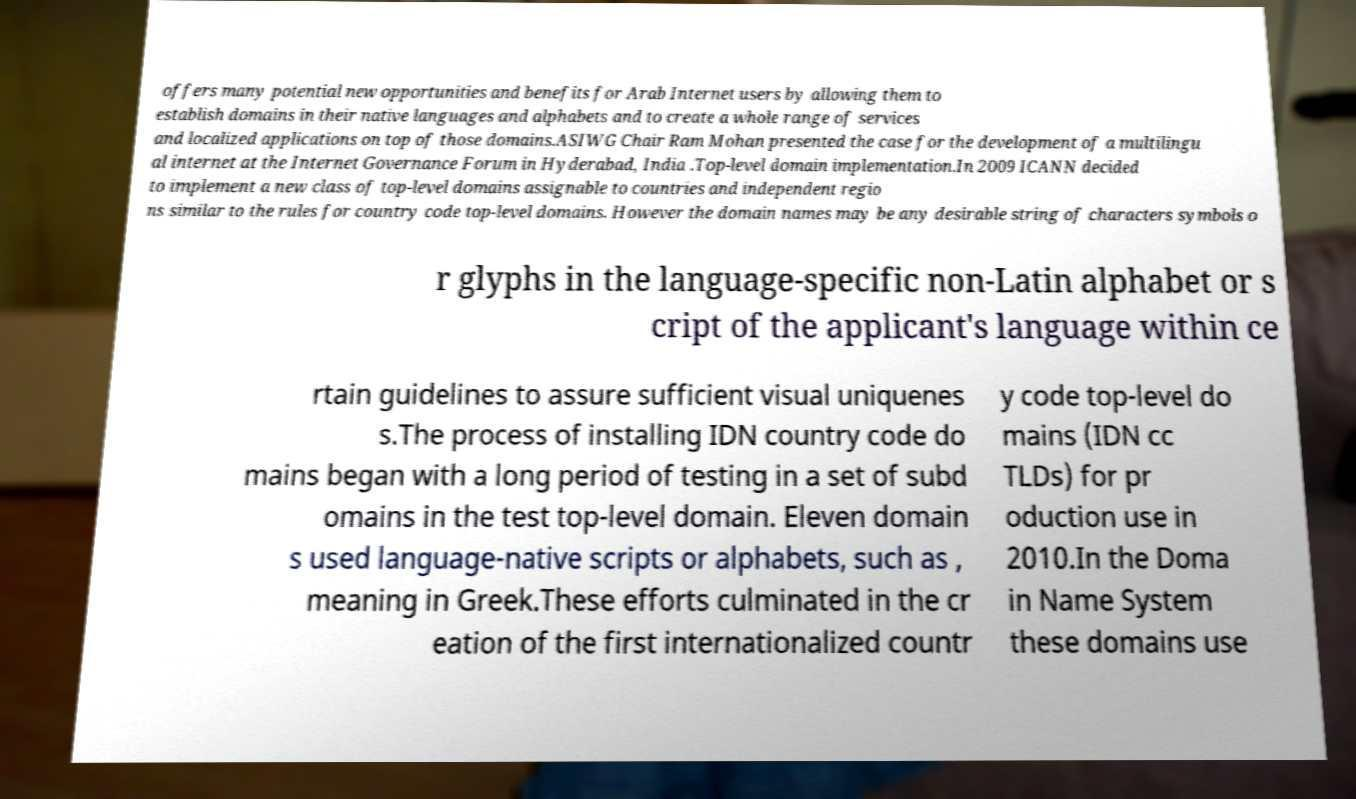There's text embedded in this image that I need extracted. Can you transcribe it verbatim? offers many potential new opportunities and benefits for Arab Internet users by allowing them to establish domains in their native languages and alphabets and to create a whole range of services and localized applications on top of those domains.ASIWG Chair Ram Mohan presented the case for the development of a multilingu al internet at the Internet Governance Forum in Hyderabad, India .Top-level domain implementation.In 2009 ICANN decided to implement a new class of top-level domains assignable to countries and independent regio ns similar to the rules for country code top-level domains. However the domain names may be any desirable string of characters symbols o r glyphs in the language-specific non-Latin alphabet or s cript of the applicant's language within ce rtain guidelines to assure sufficient visual uniquenes s.The process of installing IDN country code do mains began with a long period of testing in a set of subd omains in the test top-level domain. Eleven domain s used language-native scripts or alphabets, such as , meaning in Greek.These efforts culminated in the cr eation of the first internationalized countr y code top-level do mains (IDN cc TLDs) for pr oduction use in 2010.In the Doma in Name System these domains use 